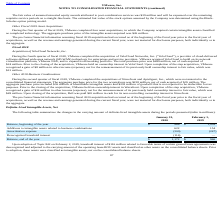From Vmware's financial document, Which years does the table provide information for the changes in the carrying amount of definite-lived intangible assets? The document shows two values: 2020 and 2019. From the document: "Other Fiscal 2019 Asset Acquisitions e pro forma financial information assuming fiscal 2020 acquisitions had occurred as of the beginning of the fisca..." Also, What was the amortization expense in 2020? According to the financial document, (300) (in millions). The relevant text states: "Amortization expense (300) (247)..." Also, What was the balance at the beginning of the year in 2019? According to the financial document, 1,059 (in millions). The relevant text states: "Balance, beginning of the year $ 966 $ 1,059..." Also, can you calculate: What was the change in Additions to intangible assets between 2019 and 2020? Based on the calculation: 622-154, the result is 468 (in millions). This is based on the information: "ntangible assets related to business combinations 622 154 gible assets related to business combinations 622 154..." The key data points involved are: 154, 622. Also, How many years did balance at the beginning of the year exceed $1,000 million? Based on the analysis, there are 1 instances. The counting process: 2019. Also, can you calculate: What was the percentage change in the balance at the end of the year between 2019 and 2020? To answer this question, I need to perform calculations using the financial data. The calculation is: (1,172-966)/966, which equals 21.33 (percentage). This is based on the information: "Balance, beginning of the year $ 966 $ 1,059 Balance, end of the year $ 1,172 $ 966..." The key data points involved are: 1,172, 966. 